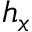Convert formula to latex. <formula><loc_0><loc_0><loc_500><loc_500>h _ { x }</formula> 